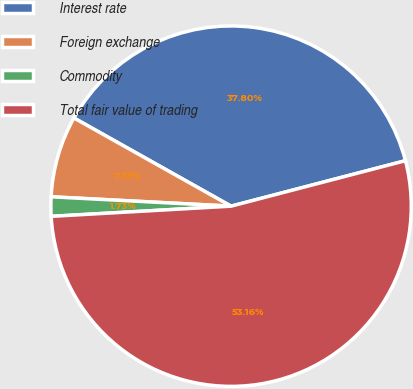Convert chart to OTSL. <chart><loc_0><loc_0><loc_500><loc_500><pie_chart><fcel>Interest rate<fcel>Foreign exchange<fcel>Commodity<fcel>Total fair value of trading<nl><fcel>37.8%<fcel>7.31%<fcel>1.73%<fcel>53.16%<nl></chart> 